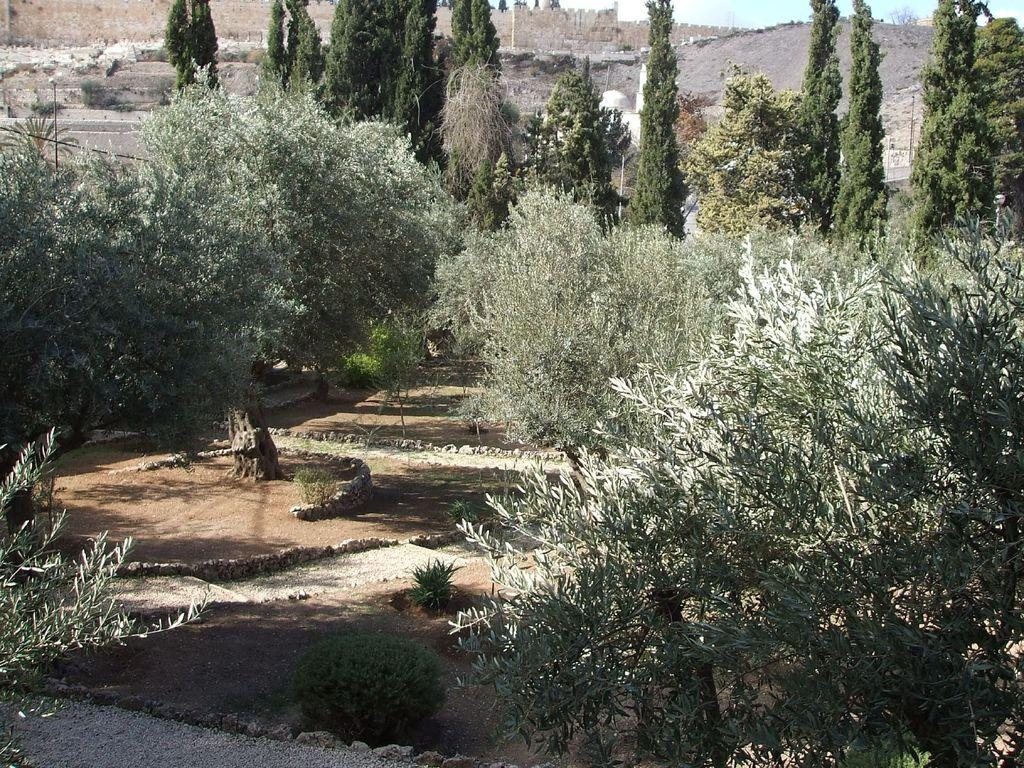What type of location is shown in the image? The image depicts a garden. What types of vegetation can be seen in the image? There are plants and trees in the image. What is visible in the background of the image? There is a wall in the background of the image. What is visible at the top of the image? The sky is visible at the top of the image. Which actor is performing in the garden in the image? There are no actors or performances depicted in the image; it shows a garden with plants, trees, a wall, and the sky. 